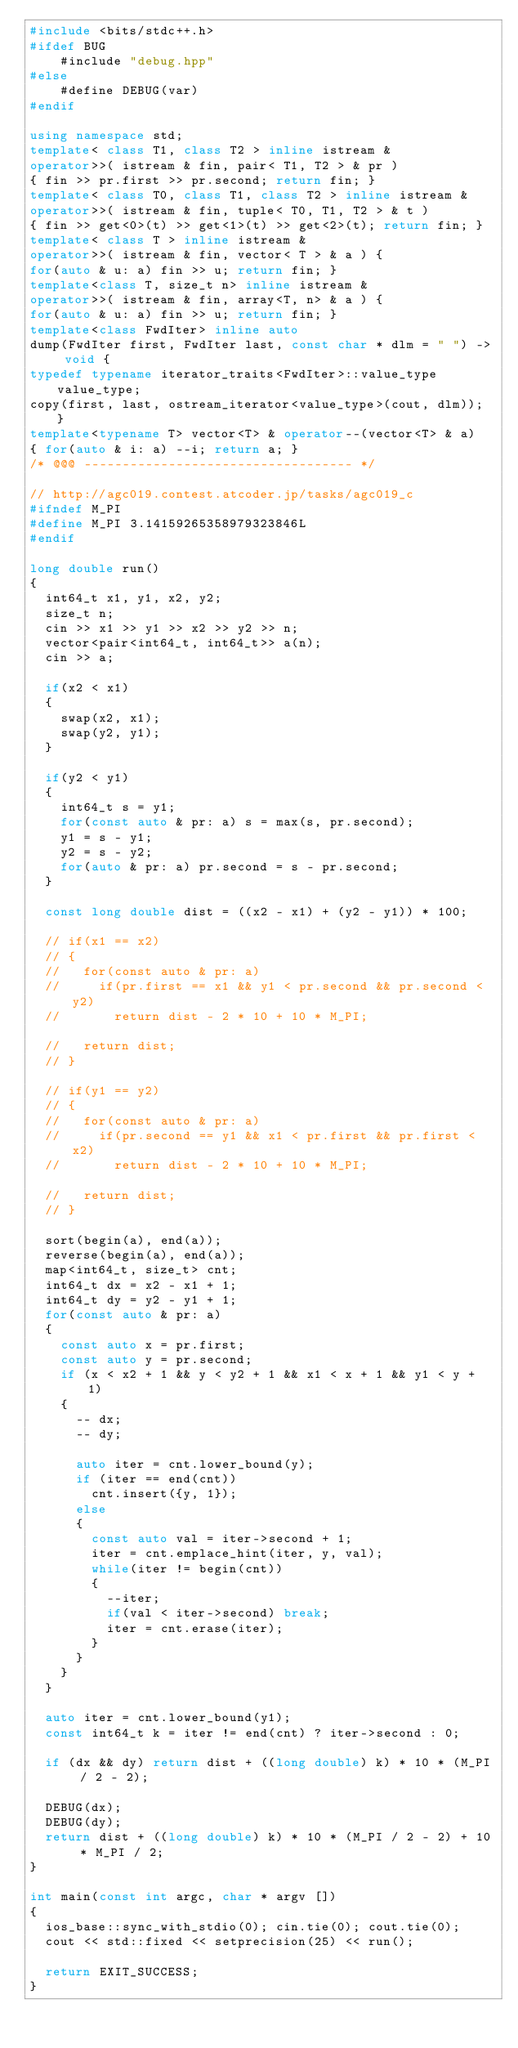Convert code to text. <code><loc_0><loc_0><loc_500><loc_500><_C++_>#include <bits/stdc++.h>
#ifdef BUG
    #include "debug.hpp"
#else
    #define DEBUG(var)
#endif

using namespace std;
template< class T1, class T2 > inline istream &
operator>>( istream & fin, pair< T1, T2 > & pr )
{ fin >> pr.first >> pr.second; return fin; }
template< class T0, class T1, class T2 > inline istream &
operator>>( istream & fin, tuple< T0, T1, T2 > & t )
{ fin >> get<0>(t) >> get<1>(t) >> get<2>(t); return fin; }
template< class T > inline istream &
operator>>( istream & fin, vector< T > & a ) {
for(auto & u: a) fin >> u; return fin; }
template<class T, size_t n> inline istream &
operator>>( istream & fin, array<T, n> & a ) {
for(auto & u: a) fin >> u; return fin; }
template<class FwdIter> inline auto
dump(FwdIter first, FwdIter last, const char * dlm = " ") -> void {
typedef typename iterator_traits<FwdIter>::value_type value_type;
copy(first, last, ostream_iterator<value_type>(cout, dlm)); }
template<typename T> vector<T> & operator--(vector<T> & a)
{ for(auto & i: a) --i; return a; }
/* @@@ ----------------------------------- */

// http://agc019.contest.atcoder.jp/tasks/agc019_c
#ifndef M_PI
#define M_PI 3.14159265358979323846L
#endif

long double run()
{
  int64_t x1, y1, x2, y2;
  size_t n;
  cin >> x1 >> y1 >> x2 >> y2 >> n;
  vector<pair<int64_t, int64_t>> a(n);
  cin >> a;

  if(x2 < x1)
  {
    swap(x2, x1);
    swap(y2, y1);
  }

  if(y2 < y1)
  {
    int64_t s = y1;
    for(const auto & pr: a) s = max(s, pr.second);
    y1 = s - y1;
    y2 = s - y2;
    for(auto & pr: a) pr.second = s - pr.second;
  }

  const long double dist = ((x2 - x1) + (y2 - y1)) * 100;

  // if(x1 == x2)
  // {
  //   for(const auto & pr: a)
  //     if(pr.first == x1 && y1 < pr.second && pr.second < y2)
  //       return dist - 2 * 10 + 10 * M_PI;

  //   return dist;
  // }

  // if(y1 == y2)
  // {
  //   for(const auto & pr: a)
  //     if(pr.second == y1 && x1 < pr.first && pr.first < x2)
  //       return dist - 2 * 10 + 10 * M_PI;

  //   return dist;
  // }

  sort(begin(a), end(a));
  reverse(begin(a), end(a));
  map<int64_t, size_t> cnt;
  int64_t dx = x2 - x1 + 1;
  int64_t dy = y2 - y1 + 1;
  for(const auto & pr: a)
  {
    const auto x = pr.first;
    const auto y = pr.second;
    if (x < x2 + 1 && y < y2 + 1 && x1 < x + 1 && y1 < y + 1)
    {
      -- dx;
      -- dy;

      auto iter = cnt.lower_bound(y);
      if (iter == end(cnt))
        cnt.insert({y, 1});
      else
      {
        const auto val = iter->second + 1;
        iter = cnt.emplace_hint(iter, y, val);
        while(iter != begin(cnt))
        {
          --iter;
          if(val < iter->second) break;
          iter = cnt.erase(iter);
        }
      }
    }
  }

  auto iter = cnt.lower_bound(y1);
  const int64_t k = iter != end(cnt) ? iter->second : 0;

  if (dx && dy) return dist + ((long double) k) * 10 * (M_PI / 2 - 2);

  DEBUG(dx);
  DEBUG(dy);
  return dist + ((long double) k) * 10 * (M_PI / 2 - 2) + 10 * M_PI / 2;
}

int main(const int argc, char * argv [])
{
  ios_base::sync_with_stdio(0); cin.tie(0); cout.tie(0);
  cout << std::fixed << setprecision(25) << run();

  return EXIT_SUCCESS;
}
</code> 